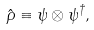<formula> <loc_0><loc_0><loc_500><loc_500>\hat { \rho } \equiv \psi \otimes \psi ^ { \dagger } ,</formula> 